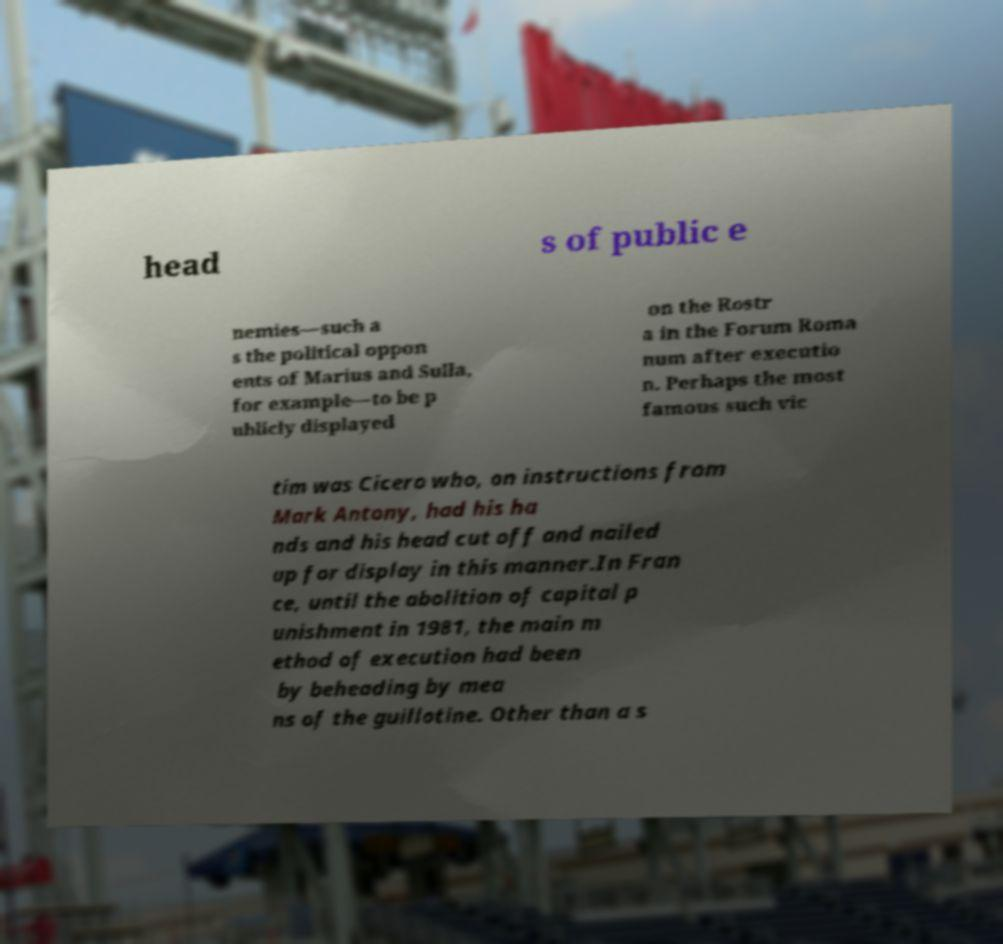Please read and relay the text visible in this image. What does it say? head s of public e nemies—such a s the political oppon ents of Marius and Sulla, for example—to be p ublicly displayed on the Rostr a in the Forum Roma num after executio n. Perhaps the most famous such vic tim was Cicero who, on instructions from Mark Antony, had his ha nds and his head cut off and nailed up for display in this manner.In Fran ce, until the abolition of capital p unishment in 1981, the main m ethod of execution had been by beheading by mea ns of the guillotine. Other than a s 